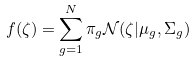Convert formula to latex. <formula><loc_0><loc_0><loc_500><loc_500>f ( \zeta ) = \sum _ { g = 1 } ^ { N } \pi _ { g } \mathcal { N } ( \zeta | \mu _ { g } , \Sigma _ { g } )</formula> 